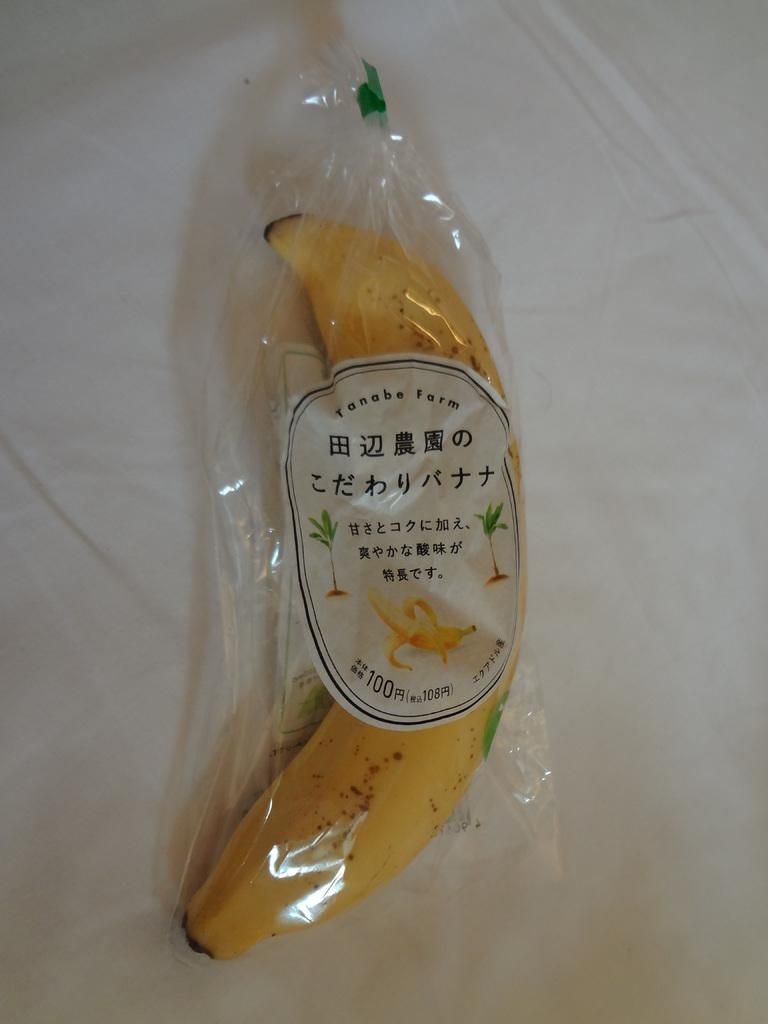<image>
Present a compact description of the photo's key features. Banana in a wrapper from Tanabe Farms on top of a white cloth. 